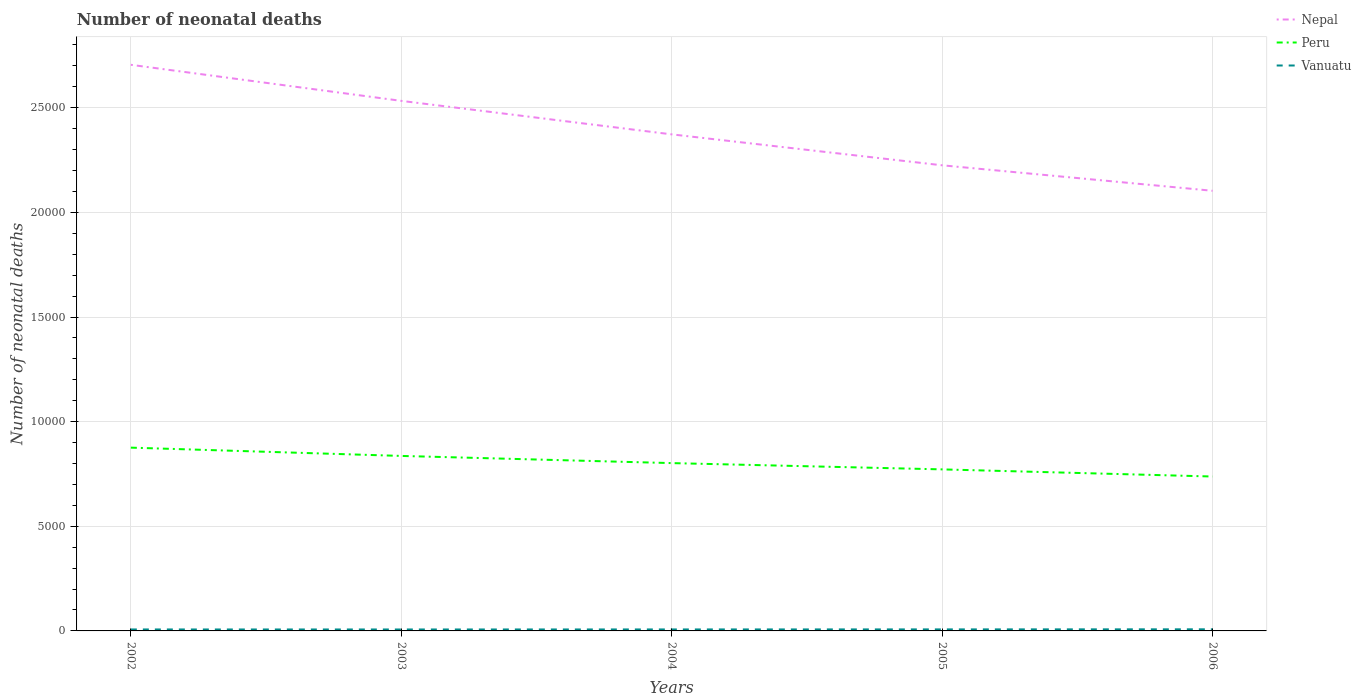Is the number of lines equal to the number of legend labels?
Make the answer very short. Yes. Across all years, what is the maximum number of neonatal deaths in in Vanuatu?
Ensure brevity in your answer.  69. In which year was the number of neonatal deaths in in Nepal maximum?
Make the answer very short. 2006. What is the total number of neonatal deaths in in Vanuatu in the graph?
Provide a succinct answer. 1. What is the difference between the highest and the second highest number of neonatal deaths in in Peru?
Your response must be concise. 1380. Is the number of neonatal deaths in in Vanuatu strictly greater than the number of neonatal deaths in in Peru over the years?
Your answer should be very brief. Yes. Are the values on the major ticks of Y-axis written in scientific E-notation?
Ensure brevity in your answer.  No. Does the graph contain grids?
Give a very brief answer. Yes. What is the title of the graph?
Ensure brevity in your answer.  Number of neonatal deaths. What is the label or title of the X-axis?
Offer a very short reply. Years. What is the label or title of the Y-axis?
Your answer should be very brief. Number of neonatal deaths. What is the Number of neonatal deaths in Nepal in 2002?
Your response must be concise. 2.71e+04. What is the Number of neonatal deaths in Peru in 2002?
Give a very brief answer. 8758. What is the Number of neonatal deaths in Nepal in 2003?
Give a very brief answer. 2.53e+04. What is the Number of neonatal deaths of Peru in 2003?
Your response must be concise. 8362. What is the Number of neonatal deaths of Nepal in 2004?
Offer a very short reply. 2.37e+04. What is the Number of neonatal deaths of Peru in 2004?
Provide a short and direct response. 8019. What is the Number of neonatal deaths of Vanuatu in 2004?
Your response must be concise. 71. What is the Number of neonatal deaths of Nepal in 2005?
Provide a short and direct response. 2.22e+04. What is the Number of neonatal deaths in Peru in 2005?
Offer a very short reply. 7719. What is the Number of neonatal deaths in Nepal in 2006?
Your response must be concise. 2.10e+04. What is the Number of neonatal deaths in Peru in 2006?
Give a very brief answer. 7378. What is the Number of neonatal deaths in Vanuatu in 2006?
Give a very brief answer. 77. Across all years, what is the maximum Number of neonatal deaths of Nepal?
Offer a terse response. 2.71e+04. Across all years, what is the maximum Number of neonatal deaths in Peru?
Offer a terse response. 8758. Across all years, what is the minimum Number of neonatal deaths of Nepal?
Ensure brevity in your answer.  2.10e+04. Across all years, what is the minimum Number of neonatal deaths in Peru?
Ensure brevity in your answer.  7378. Across all years, what is the minimum Number of neonatal deaths in Vanuatu?
Your answer should be compact. 69. What is the total Number of neonatal deaths in Nepal in the graph?
Ensure brevity in your answer.  1.19e+05. What is the total Number of neonatal deaths of Peru in the graph?
Provide a short and direct response. 4.02e+04. What is the total Number of neonatal deaths in Vanuatu in the graph?
Your answer should be very brief. 360. What is the difference between the Number of neonatal deaths of Nepal in 2002 and that in 2003?
Provide a short and direct response. 1723. What is the difference between the Number of neonatal deaths in Peru in 2002 and that in 2003?
Your answer should be compact. 396. What is the difference between the Number of neonatal deaths in Vanuatu in 2002 and that in 2003?
Provide a succinct answer. 1. What is the difference between the Number of neonatal deaths of Nepal in 2002 and that in 2004?
Your response must be concise. 3324. What is the difference between the Number of neonatal deaths of Peru in 2002 and that in 2004?
Offer a very short reply. 739. What is the difference between the Number of neonatal deaths of Vanuatu in 2002 and that in 2004?
Offer a terse response. -1. What is the difference between the Number of neonatal deaths of Nepal in 2002 and that in 2005?
Your answer should be very brief. 4802. What is the difference between the Number of neonatal deaths of Peru in 2002 and that in 2005?
Give a very brief answer. 1039. What is the difference between the Number of neonatal deaths in Vanuatu in 2002 and that in 2005?
Offer a very short reply. -3. What is the difference between the Number of neonatal deaths of Nepal in 2002 and that in 2006?
Make the answer very short. 6020. What is the difference between the Number of neonatal deaths in Peru in 2002 and that in 2006?
Provide a short and direct response. 1380. What is the difference between the Number of neonatal deaths of Vanuatu in 2002 and that in 2006?
Provide a short and direct response. -7. What is the difference between the Number of neonatal deaths in Nepal in 2003 and that in 2004?
Offer a very short reply. 1601. What is the difference between the Number of neonatal deaths of Peru in 2003 and that in 2004?
Offer a terse response. 343. What is the difference between the Number of neonatal deaths in Vanuatu in 2003 and that in 2004?
Offer a very short reply. -2. What is the difference between the Number of neonatal deaths in Nepal in 2003 and that in 2005?
Offer a very short reply. 3079. What is the difference between the Number of neonatal deaths of Peru in 2003 and that in 2005?
Your answer should be very brief. 643. What is the difference between the Number of neonatal deaths of Nepal in 2003 and that in 2006?
Your response must be concise. 4297. What is the difference between the Number of neonatal deaths in Peru in 2003 and that in 2006?
Your response must be concise. 984. What is the difference between the Number of neonatal deaths of Nepal in 2004 and that in 2005?
Your answer should be compact. 1478. What is the difference between the Number of neonatal deaths in Peru in 2004 and that in 2005?
Offer a very short reply. 300. What is the difference between the Number of neonatal deaths of Vanuatu in 2004 and that in 2005?
Make the answer very short. -2. What is the difference between the Number of neonatal deaths of Nepal in 2004 and that in 2006?
Offer a very short reply. 2696. What is the difference between the Number of neonatal deaths of Peru in 2004 and that in 2006?
Provide a succinct answer. 641. What is the difference between the Number of neonatal deaths in Nepal in 2005 and that in 2006?
Make the answer very short. 1218. What is the difference between the Number of neonatal deaths of Peru in 2005 and that in 2006?
Your answer should be compact. 341. What is the difference between the Number of neonatal deaths of Nepal in 2002 and the Number of neonatal deaths of Peru in 2003?
Your answer should be very brief. 1.87e+04. What is the difference between the Number of neonatal deaths in Nepal in 2002 and the Number of neonatal deaths in Vanuatu in 2003?
Provide a short and direct response. 2.70e+04. What is the difference between the Number of neonatal deaths of Peru in 2002 and the Number of neonatal deaths of Vanuatu in 2003?
Give a very brief answer. 8689. What is the difference between the Number of neonatal deaths in Nepal in 2002 and the Number of neonatal deaths in Peru in 2004?
Make the answer very short. 1.90e+04. What is the difference between the Number of neonatal deaths in Nepal in 2002 and the Number of neonatal deaths in Vanuatu in 2004?
Keep it short and to the point. 2.70e+04. What is the difference between the Number of neonatal deaths of Peru in 2002 and the Number of neonatal deaths of Vanuatu in 2004?
Offer a terse response. 8687. What is the difference between the Number of neonatal deaths of Nepal in 2002 and the Number of neonatal deaths of Peru in 2005?
Your answer should be compact. 1.93e+04. What is the difference between the Number of neonatal deaths in Nepal in 2002 and the Number of neonatal deaths in Vanuatu in 2005?
Provide a short and direct response. 2.70e+04. What is the difference between the Number of neonatal deaths of Peru in 2002 and the Number of neonatal deaths of Vanuatu in 2005?
Provide a short and direct response. 8685. What is the difference between the Number of neonatal deaths in Nepal in 2002 and the Number of neonatal deaths in Peru in 2006?
Provide a short and direct response. 1.97e+04. What is the difference between the Number of neonatal deaths in Nepal in 2002 and the Number of neonatal deaths in Vanuatu in 2006?
Your answer should be very brief. 2.70e+04. What is the difference between the Number of neonatal deaths of Peru in 2002 and the Number of neonatal deaths of Vanuatu in 2006?
Keep it short and to the point. 8681. What is the difference between the Number of neonatal deaths in Nepal in 2003 and the Number of neonatal deaths in Peru in 2004?
Your answer should be very brief. 1.73e+04. What is the difference between the Number of neonatal deaths of Nepal in 2003 and the Number of neonatal deaths of Vanuatu in 2004?
Your answer should be very brief. 2.53e+04. What is the difference between the Number of neonatal deaths in Peru in 2003 and the Number of neonatal deaths in Vanuatu in 2004?
Offer a terse response. 8291. What is the difference between the Number of neonatal deaths of Nepal in 2003 and the Number of neonatal deaths of Peru in 2005?
Keep it short and to the point. 1.76e+04. What is the difference between the Number of neonatal deaths in Nepal in 2003 and the Number of neonatal deaths in Vanuatu in 2005?
Provide a short and direct response. 2.53e+04. What is the difference between the Number of neonatal deaths in Peru in 2003 and the Number of neonatal deaths in Vanuatu in 2005?
Keep it short and to the point. 8289. What is the difference between the Number of neonatal deaths of Nepal in 2003 and the Number of neonatal deaths of Peru in 2006?
Keep it short and to the point. 1.80e+04. What is the difference between the Number of neonatal deaths in Nepal in 2003 and the Number of neonatal deaths in Vanuatu in 2006?
Make the answer very short. 2.53e+04. What is the difference between the Number of neonatal deaths of Peru in 2003 and the Number of neonatal deaths of Vanuatu in 2006?
Your response must be concise. 8285. What is the difference between the Number of neonatal deaths in Nepal in 2004 and the Number of neonatal deaths in Peru in 2005?
Provide a succinct answer. 1.60e+04. What is the difference between the Number of neonatal deaths in Nepal in 2004 and the Number of neonatal deaths in Vanuatu in 2005?
Your answer should be compact. 2.37e+04. What is the difference between the Number of neonatal deaths of Peru in 2004 and the Number of neonatal deaths of Vanuatu in 2005?
Your response must be concise. 7946. What is the difference between the Number of neonatal deaths of Nepal in 2004 and the Number of neonatal deaths of Peru in 2006?
Your response must be concise. 1.63e+04. What is the difference between the Number of neonatal deaths in Nepal in 2004 and the Number of neonatal deaths in Vanuatu in 2006?
Ensure brevity in your answer.  2.36e+04. What is the difference between the Number of neonatal deaths of Peru in 2004 and the Number of neonatal deaths of Vanuatu in 2006?
Provide a succinct answer. 7942. What is the difference between the Number of neonatal deaths of Nepal in 2005 and the Number of neonatal deaths of Peru in 2006?
Provide a short and direct response. 1.49e+04. What is the difference between the Number of neonatal deaths of Nepal in 2005 and the Number of neonatal deaths of Vanuatu in 2006?
Your answer should be very brief. 2.22e+04. What is the difference between the Number of neonatal deaths in Peru in 2005 and the Number of neonatal deaths in Vanuatu in 2006?
Offer a very short reply. 7642. What is the average Number of neonatal deaths in Nepal per year?
Provide a succinct answer. 2.39e+04. What is the average Number of neonatal deaths of Peru per year?
Keep it short and to the point. 8047.2. In the year 2002, what is the difference between the Number of neonatal deaths in Nepal and Number of neonatal deaths in Peru?
Ensure brevity in your answer.  1.83e+04. In the year 2002, what is the difference between the Number of neonatal deaths in Nepal and Number of neonatal deaths in Vanuatu?
Make the answer very short. 2.70e+04. In the year 2002, what is the difference between the Number of neonatal deaths in Peru and Number of neonatal deaths in Vanuatu?
Your answer should be compact. 8688. In the year 2003, what is the difference between the Number of neonatal deaths of Nepal and Number of neonatal deaths of Peru?
Give a very brief answer. 1.70e+04. In the year 2003, what is the difference between the Number of neonatal deaths in Nepal and Number of neonatal deaths in Vanuatu?
Your answer should be compact. 2.53e+04. In the year 2003, what is the difference between the Number of neonatal deaths of Peru and Number of neonatal deaths of Vanuatu?
Your response must be concise. 8293. In the year 2004, what is the difference between the Number of neonatal deaths in Nepal and Number of neonatal deaths in Peru?
Offer a terse response. 1.57e+04. In the year 2004, what is the difference between the Number of neonatal deaths in Nepal and Number of neonatal deaths in Vanuatu?
Keep it short and to the point. 2.37e+04. In the year 2004, what is the difference between the Number of neonatal deaths of Peru and Number of neonatal deaths of Vanuatu?
Your answer should be very brief. 7948. In the year 2005, what is the difference between the Number of neonatal deaths in Nepal and Number of neonatal deaths in Peru?
Make the answer very short. 1.45e+04. In the year 2005, what is the difference between the Number of neonatal deaths of Nepal and Number of neonatal deaths of Vanuatu?
Your answer should be compact. 2.22e+04. In the year 2005, what is the difference between the Number of neonatal deaths in Peru and Number of neonatal deaths in Vanuatu?
Offer a terse response. 7646. In the year 2006, what is the difference between the Number of neonatal deaths in Nepal and Number of neonatal deaths in Peru?
Your response must be concise. 1.37e+04. In the year 2006, what is the difference between the Number of neonatal deaths in Nepal and Number of neonatal deaths in Vanuatu?
Your answer should be very brief. 2.10e+04. In the year 2006, what is the difference between the Number of neonatal deaths of Peru and Number of neonatal deaths of Vanuatu?
Your response must be concise. 7301. What is the ratio of the Number of neonatal deaths in Nepal in 2002 to that in 2003?
Offer a very short reply. 1.07. What is the ratio of the Number of neonatal deaths in Peru in 2002 to that in 2003?
Your answer should be very brief. 1.05. What is the ratio of the Number of neonatal deaths in Vanuatu in 2002 to that in 2003?
Ensure brevity in your answer.  1.01. What is the ratio of the Number of neonatal deaths in Nepal in 2002 to that in 2004?
Your response must be concise. 1.14. What is the ratio of the Number of neonatal deaths of Peru in 2002 to that in 2004?
Keep it short and to the point. 1.09. What is the ratio of the Number of neonatal deaths of Vanuatu in 2002 to that in 2004?
Offer a very short reply. 0.99. What is the ratio of the Number of neonatal deaths of Nepal in 2002 to that in 2005?
Give a very brief answer. 1.22. What is the ratio of the Number of neonatal deaths of Peru in 2002 to that in 2005?
Your response must be concise. 1.13. What is the ratio of the Number of neonatal deaths in Vanuatu in 2002 to that in 2005?
Offer a terse response. 0.96. What is the ratio of the Number of neonatal deaths in Nepal in 2002 to that in 2006?
Your answer should be very brief. 1.29. What is the ratio of the Number of neonatal deaths in Peru in 2002 to that in 2006?
Your answer should be compact. 1.19. What is the ratio of the Number of neonatal deaths in Vanuatu in 2002 to that in 2006?
Ensure brevity in your answer.  0.91. What is the ratio of the Number of neonatal deaths of Nepal in 2003 to that in 2004?
Give a very brief answer. 1.07. What is the ratio of the Number of neonatal deaths in Peru in 2003 to that in 2004?
Your response must be concise. 1.04. What is the ratio of the Number of neonatal deaths of Vanuatu in 2003 to that in 2004?
Ensure brevity in your answer.  0.97. What is the ratio of the Number of neonatal deaths of Nepal in 2003 to that in 2005?
Make the answer very short. 1.14. What is the ratio of the Number of neonatal deaths in Vanuatu in 2003 to that in 2005?
Offer a terse response. 0.95. What is the ratio of the Number of neonatal deaths in Nepal in 2003 to that in 2006?
Your response must be concise. 1.2. What is the ratio of the Number of neonatal deaths of Peru in 2003 to that in 2006?
Your answer should be very brief. 1.13. What is the ratio of the Number of neonatal deaths in Vanuatu in 2003 to that in 2006?
Keep it short and to the point. 0.9. What is the ratio of the Number of neonatal deaths in Nepal in 2004 to that in 2005?
Offer a terse response. 1.07. What is the ratio of the Number of neonatal deaths of Peru in 2004 to that in 2005?
Make the answer very short. 1.04. What is the ratio of the Number of neonatal deaths in Vanuatu in 2004 to that in 2005?
Provide a short and direct response. 0.97. What is the ratio of the Number of neonatal deaths of Nepal in 2004 to that in 2006?
Your response must be concise. 1.13. What is the ratio of the Number of neonatal deaths in Peru in 2004 to that in 2006?
Provide a short and direct response. 1.09. What is the ratio of the Number of neonatal deaths of Vanuatu in 2004 to that in 2006?
Keep it short and to the point. 0.92. What is the ratio of the Number of neonatal deaths of Nepal in 2005 to that in 2006?
Your answer should be compact. 1.06. What is the ratio of the Number of neonatal deaths of Peru in 2005 to that in 2006?
Ensure brevity in your answer.  1.05. What is the ratio of the Number of neonatal deaths in Vanuatu in 2005 to that in 2006?
Provide a succinct answer. 0.95. What is the difference between the highest and the second highest Number of neonatal deaths of Nepal?
Make the answer very short. 1723. What is the difference between the highest and the second highest Number of neonatal deaths of Peru?
Offer a terse response. 396. What is the difference between the highest and the lowest Number of neonatal deaths of Nepal?
Offer a very short reply. 6020. What is the difference between the highest and the lowest Number of neonatal deaths in Peru?
Offer a terse response. 1380. 